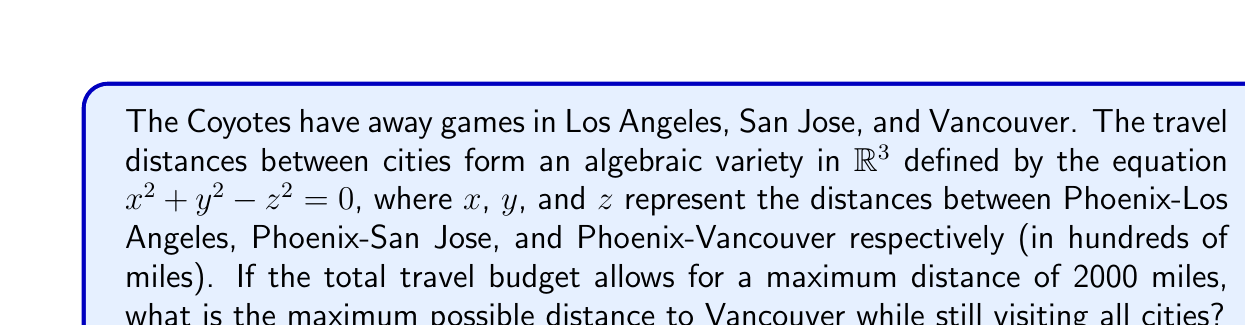Teach me how to tackle this problem. Let's approach this step-by-step:

1) The algebraic variety is given by the equation $x^2 + y^2 - z^2 = 0$.

2) We know that the total distance must not exceed 2000 miles. This gives us another constraint:
   $100x + 100y + 100z \leq 2000$
   Simplifying: $x + y + z \leq 20$

3) We want to maximize $z$, subject to these constraints.

4) From the variety equation, we can express $z$ in terms of $x$ and $y$:
   $z = \sqrt{x^2 + y^2}$

5) Substituting this into our budget constraint:
   $x + y + \sqrt{x^2 + y^2} \leq 20$

6) To maximize $z$, we need to maximize $\sqrt{x^2 + y^2}$, which occurs when $x + y + \sqrt{x^2 + y^2} = 20$.

7) Let $\sqrt{x^2 + y^2} = t$. Then $x + y = 20 - t$.

8) Squaring both sides: $x^2 + y^2 + 2xy = 400 - 40t + t^2$

9) But $x^2 + y^2 = t^2$, so:
   $t^2 + 2xy = 400 - 40t + t^2$
   $2xy = 400 - 40t$
   $xy = 200 - 20t$

10) The maximum value of $xy$ given $x + y = 20 - t$ occurs when $x = y = 10 - t/2$.

11) Substituting this back:
    $(10 - t/2)^2 = 200 - 20t$
    $100 - 10t + t^2/4 = 200 - 20t$
    $t^2/4 + 10t - 100 = 0$

12) Solving this quadratic:
    $t = 20/\sqrt{3} \approx 11.55$

13) Therefore, the maximum distance to Vancouver is:
    $z = 11.55 * 100 = 1155$ miles
Answer: 1155 miles 